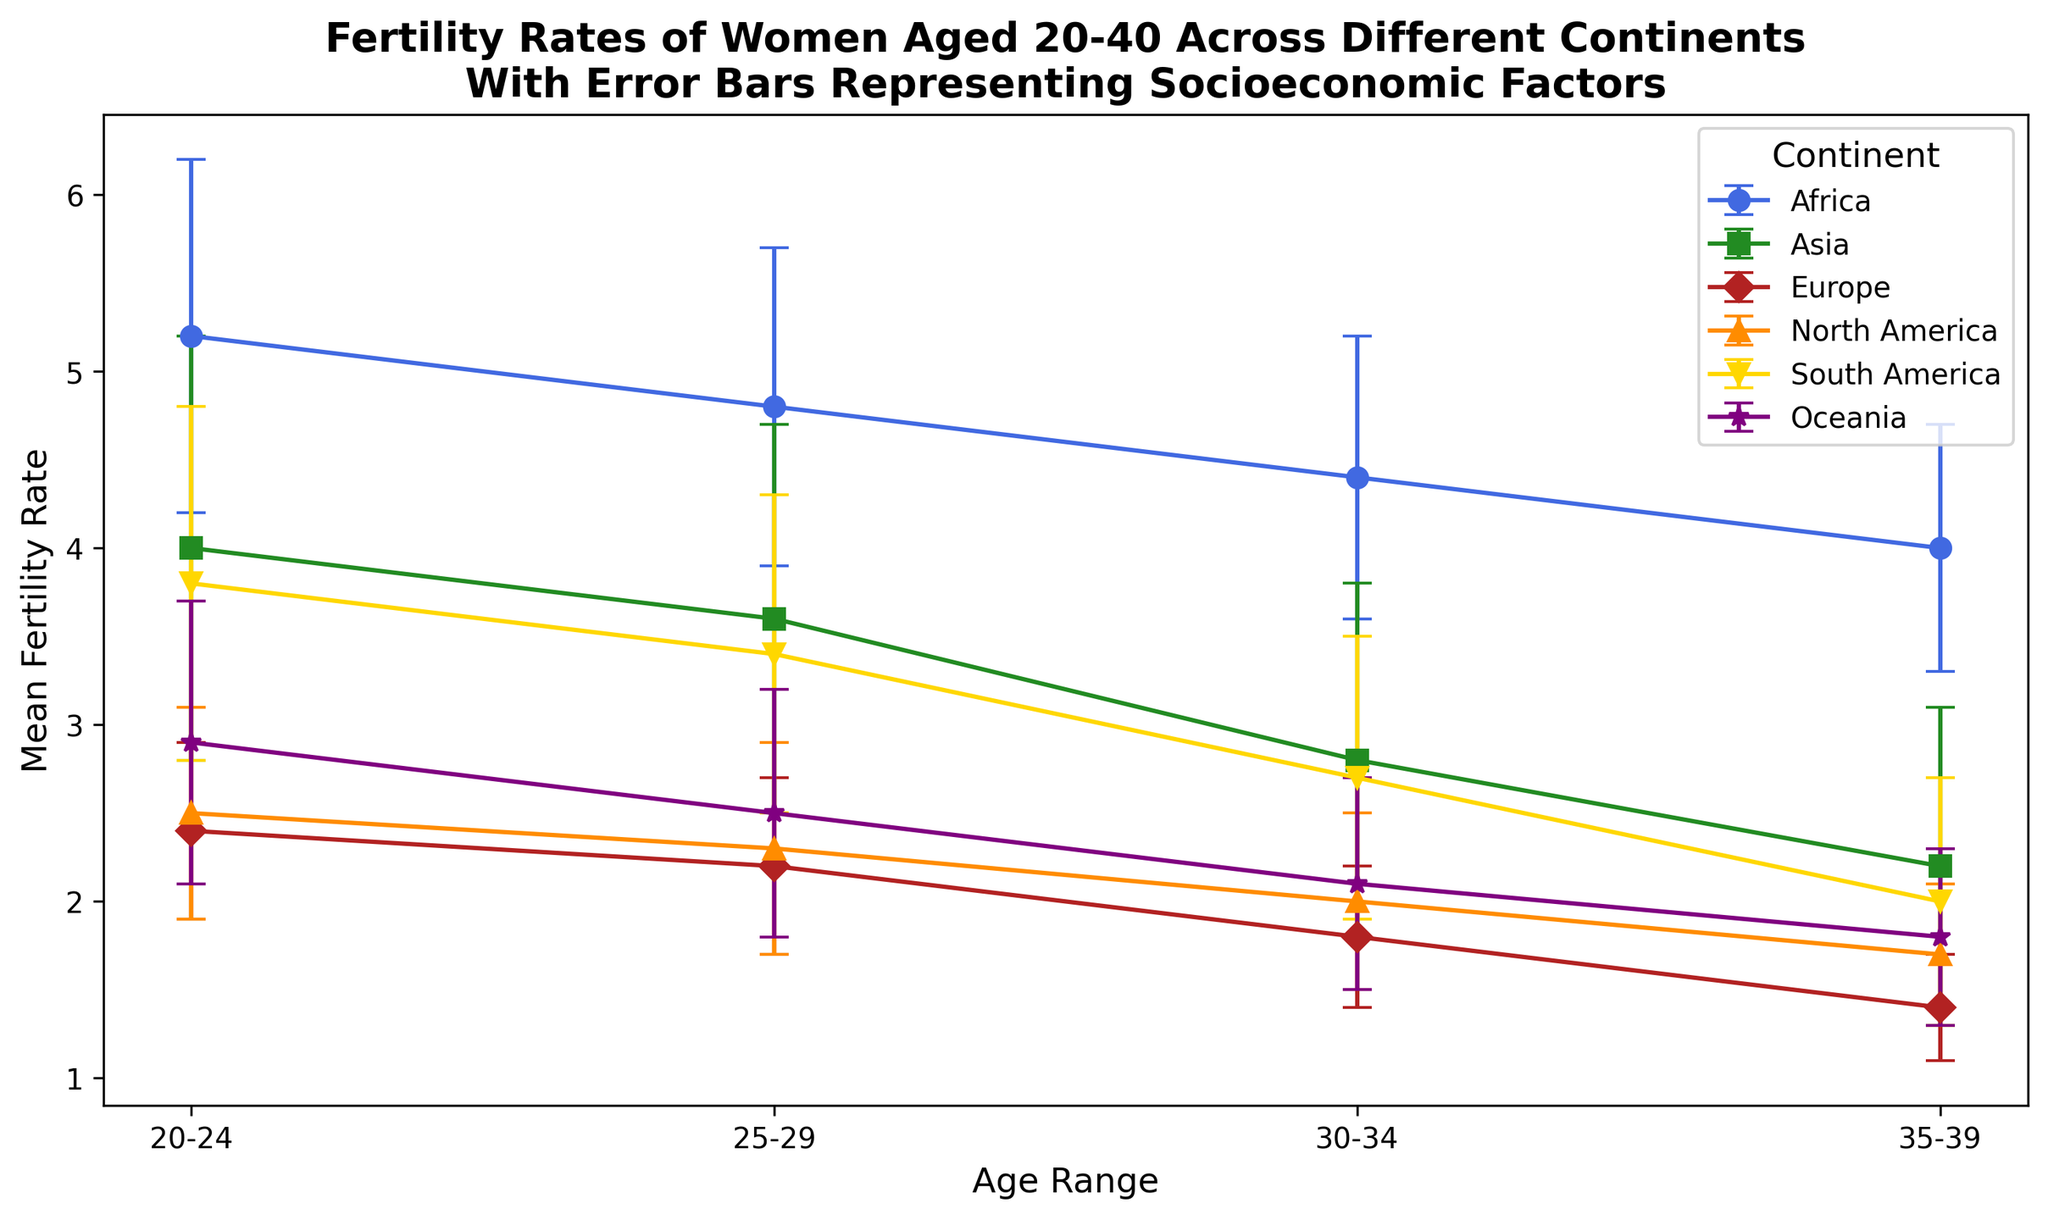What's the mean fertility rate of women aged 25-29 in North America? Refer to the plot and locate the mean fertility rate for North America for the age range 25-29, which is represented by the orange triangle.
Answer: 2.3 Which continent has the highest fertility rate for women aged 30-34? Look at the different markers and their respective heights for women aged 30-34 to see which one is the highest. Africa, represented by blue circles, has the highest mean fertility rate in this age range.
Answer: Africa What is the difference in the mean fertility rate between women aged 20-24 in Europe and Africa? Locate the mean fertility rates for women aged 20-24 in Europe (red diamonds) and Africa (blue circles) and subtract the European rate from the African rate: 5.2 - 2.4.
Answer: 2.8 Which age group shows the smallest spread in the socioeconomic factors in Asia? Compare the error bars (vertical lines) across the different age groups in Asia (green squares) to see which is the smallest. The age group 35-39 has the smallest spread.
Answer: 35-39 How does the mean fertility rate change for women in Oceania from age group 20-24 to 35-39? Look at the markers for Oceania (purple stars) from age group 20-24 to 35-39 and observe how they decrease. Subtract the mean fertility rate for 35-39 from 20-24 to understand the change: 2.9 - 1.8.
Answer: Decreases by 1.1 Are the fertility rates for the age group 25-29 in North America and Europe the same? Check the plot to see the markers for North America (orange triangles) and Europe (red diamonds) at the age range 25-29 and compare their heights.
Answer: No Which continent has the highest variability in socioeconomic factors for women aged 30-34? Check the length of the error bars (vertical lines) for the age group 30-34 across all continents, and find the continent with the longest error bar. Asia (green squares) has the highest variability.
Answer: Asia Which continent shows the most significant decline in mean fertility rate from age group 20-24 to 35-39? Compare the mean fertility rates of each continent from age 20-24 to 35-39 and observe the largest drop, which is for Africa (blue circles): 5.2 - 4.0 = 1.2.
Answer: Africa How do the error bars for socioeconomic factors differ between women aged 25-29 in Africa and South America? Compare the length of the error bars for the 25-29 age group in Africa (blue circles) and South America (yellow downward triangles). Africa has shorter error bars than South America.
Answer: Shorter in Africa What is the trend in mean fertility rates across age groups for Europe? Observe the change in height of the markers for Europe (red diamonds) from age group 20-24 to 35-39. The mean fertility rate consistently decreases.
Answer: Decreasing 